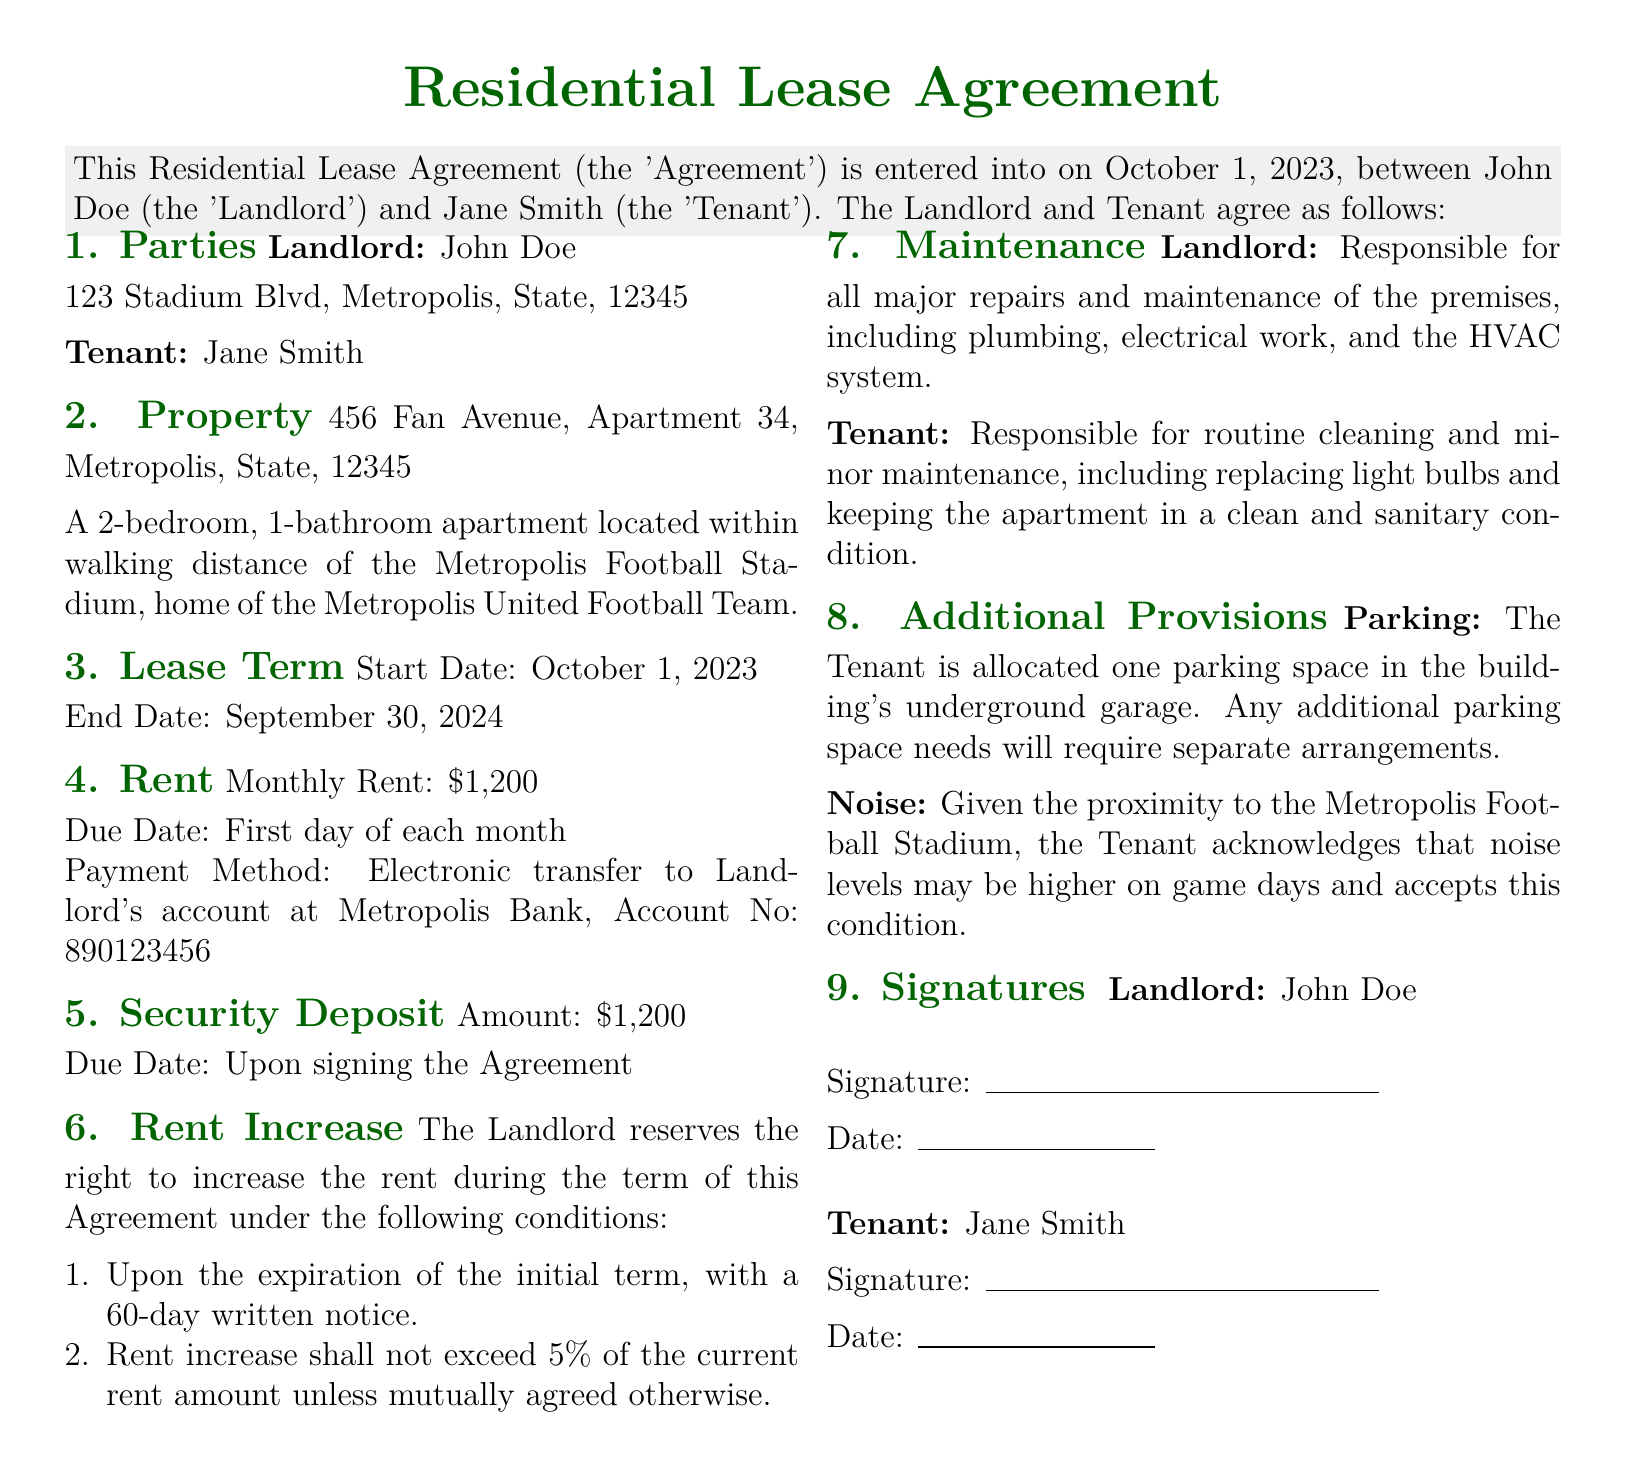What is the monthly rent? The monthly rent is explicitly stated in the rent section of the document.
Answer: $1,200 Who is the landlord? The landlord's name is mentioned at the beginning of the document.
Answer: John Doe What is the end date of the lease? The end date of the lease is noted in the lease term section.
Answer: September 30, 2024 What is the security deposit amount? The amount for the security deposit is specified in the document.
Answer: $1,200 How much notice is required for a rent increase? The conditions for rent increase specify the notice period required.
Answer: 60 days What is the maximum rent increase percentage? The lease outlines the limit on rent increases during its term.
Answer: 5% What is the tenant responsible for regarding maintenance? The document lists the tenant's responsibilities under the maintenance section.
Answer: Routine cleaning and minor maintenance What is allocated to the tenant for parking? The additional provisions section details the parking allocation for the tenant.
Answer: One parking space What is acknowledged by the tenant regarding noise? The lease includes an acknowledgement about noise conditions.
Answer: Higher noise levels on game days 